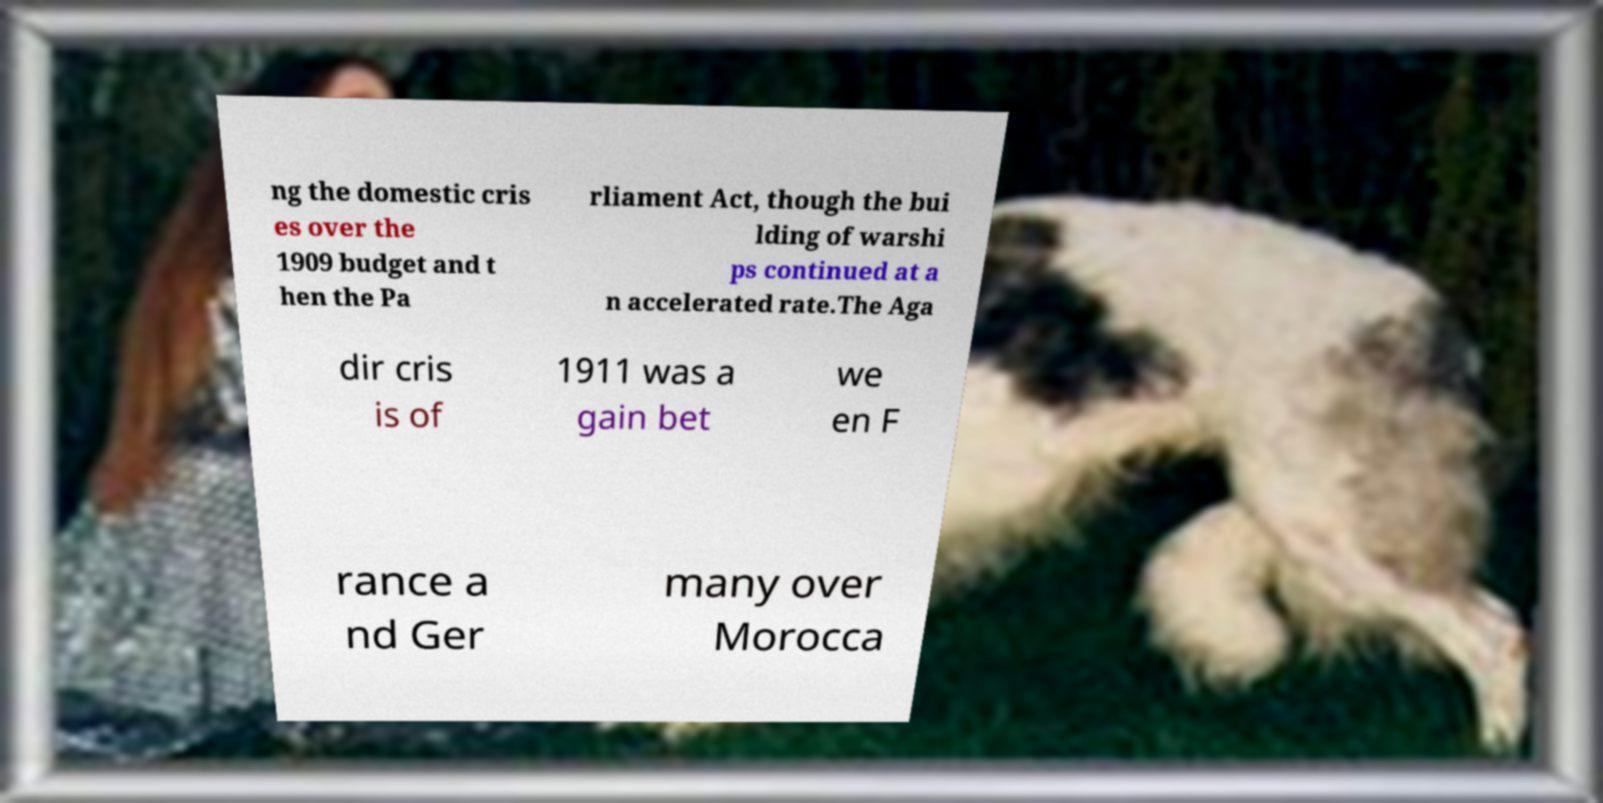Could you extract and type out the text from this image? ng the domestic cris es over the 1909 budget and t hen the Pa rliament Act, though the bui lding of warshi ps continued at a n accelerated rate.The Aga dir cris is of 1911 was a gain bet we en F rance a nd Ger many over Morocca 